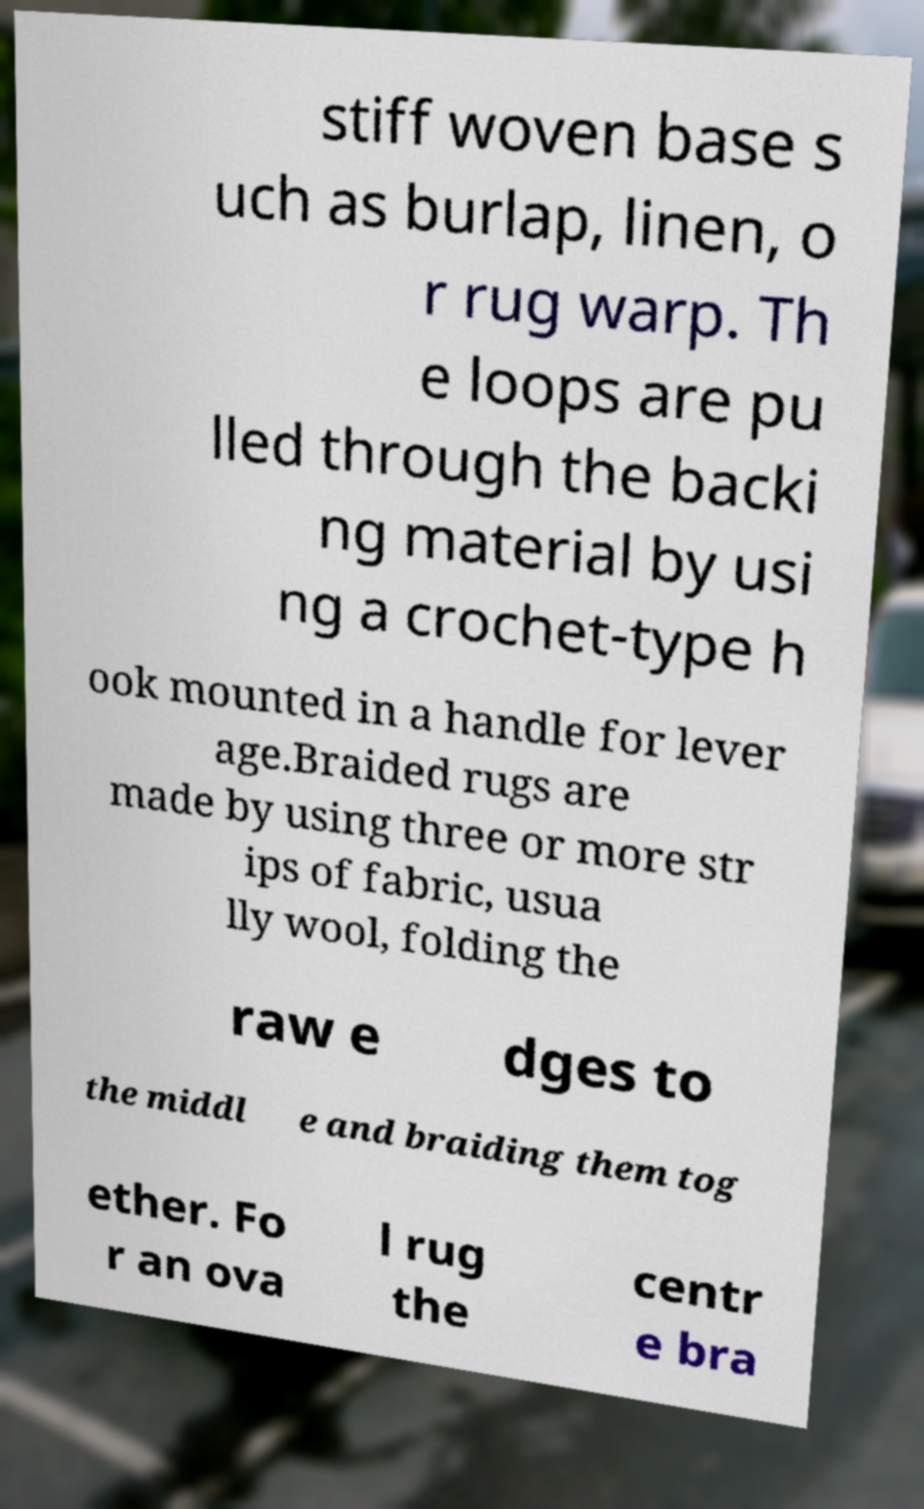Please read and relay the text visible in this image. What does it say? stiff woven base s uch as burlap, linen, o r rug warp. Th e loops are pu lled through the backi ng material by usi ng a crochet-type h ook mounted in a handle for lever age.Braided rugs are made by using three or more str ips of fabric, usua lly wool, folding the raw e dges to the middl e and braiding them tog ether. Fo r an ova l rug the centr e bra 